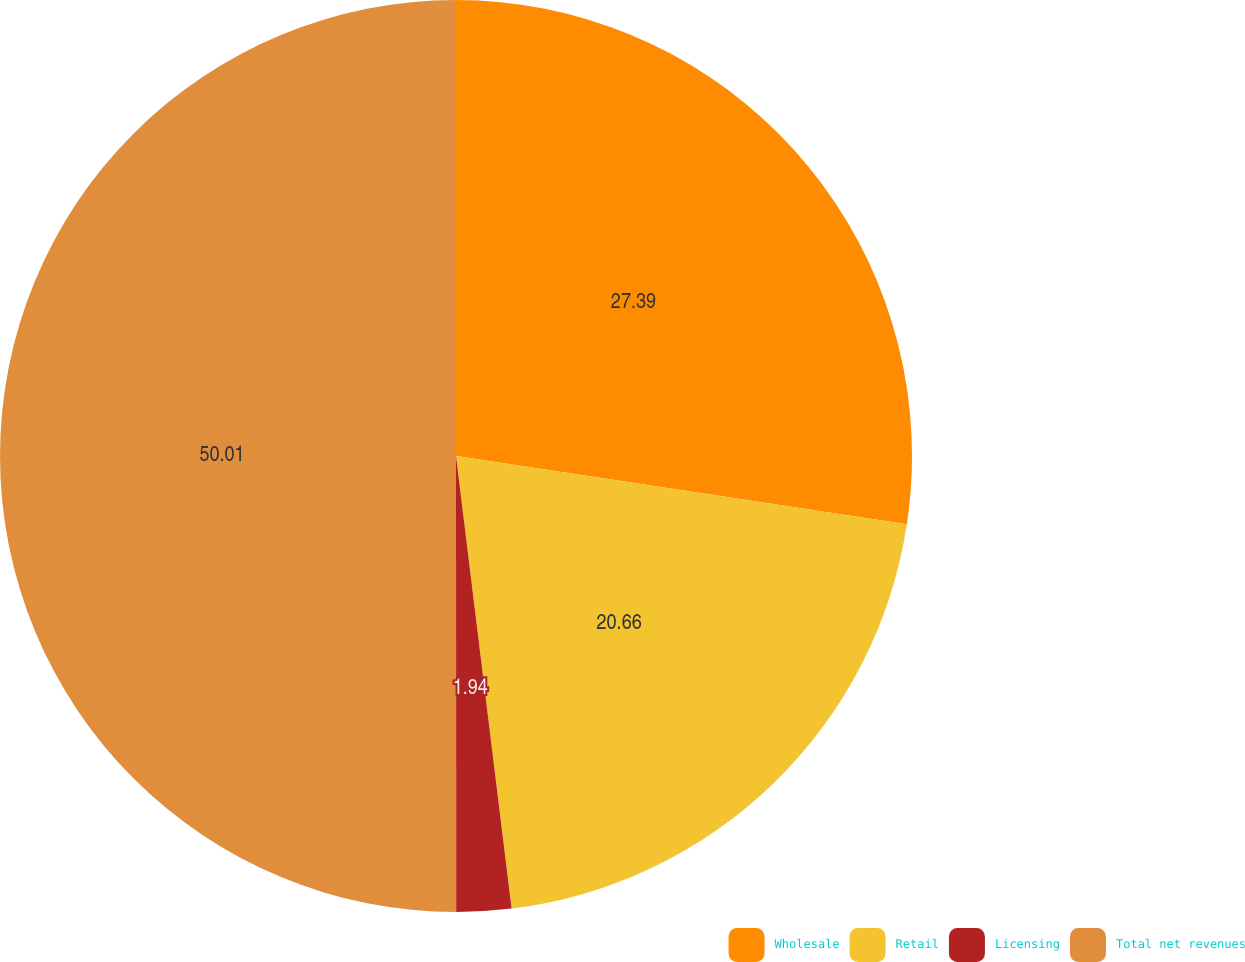Convert chart to OTSL. <chart><loc_0><loc_0><loc_500><loc_500><pie_chart><fcel>Wholesale<fcel>Retail<fcel>Licensing<fcel>Total net revenues<nl><fcel>27.39%<fcel>20.66%<fcel>1.94%<fcel>50.0%<nl></chart> 